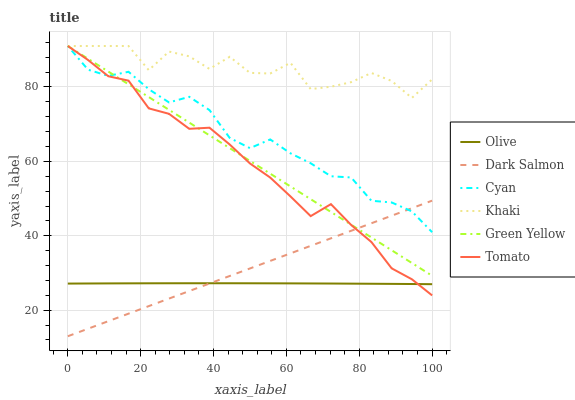Does Dark Salmon have the minimum area under the curve?
Answer yes or no. No. Does Dark Salmon have the maximum area under the curve?
Answer yes or no. No. Is Khaki the smoothest?
Answer yes or no. No. Is Dark Salmon the roughest?
Answer yes or no. No. Does Khaki have the lowest value?
Answer yes or no. No. Does Dark Salmon have the highest value?
Answer yes or no. No. Is Olive less than Khaki?
Answer yes or no. Yes. Is Green Yellow greater than Olive?
Answer yes or no. Yes. Does Olive intersect Khaki?
Answer yes or no. No. 